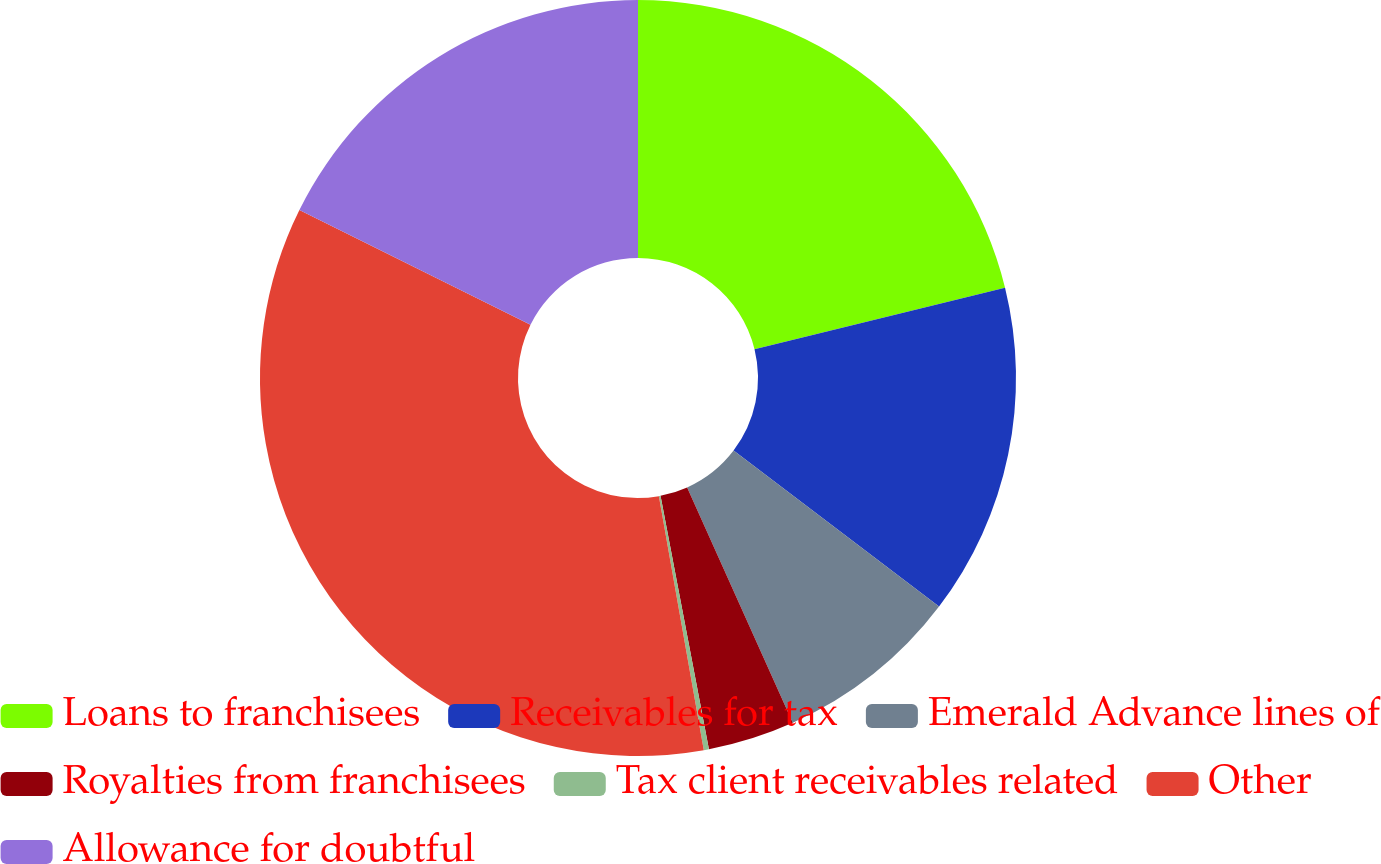<chart> <loc_0><loc_0><loc_500><loc_500><pie_chart><fcel>Loans to franchisees<fcel>Receivables for tax<fcel>Emerald Advance lines of<fcel>Royalties from franchisees<fcel>Tax client receivables related<fcel>Other<fcel>Allowance for doubtful<nl><fcel>21.16%<fcel>14.18%<fcel>7.95%<fcel>3.71%<fcel>0.22%<fcel>35.12%<fcel>17.67%<nl></chart> 